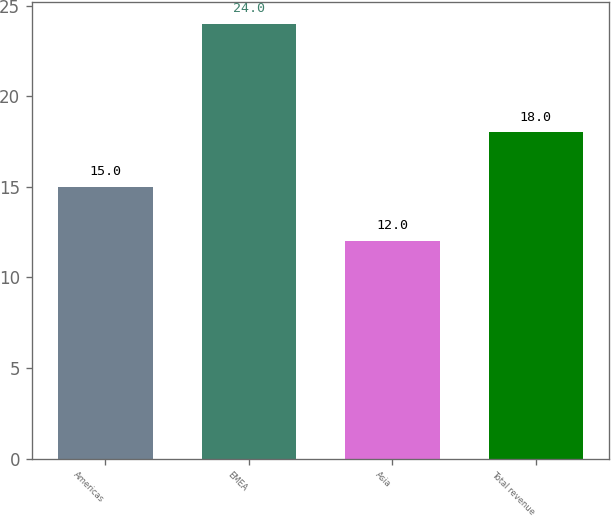<chart> <loc_0><loc_0><loc_500><loc_500><bar_chart><fcel>Americas<fcel>EMEA<fcel>Asia<fcel>Total revenue<nl><fcel>15<fcel>24<fcel>12<fcel>18<nl></chart> 